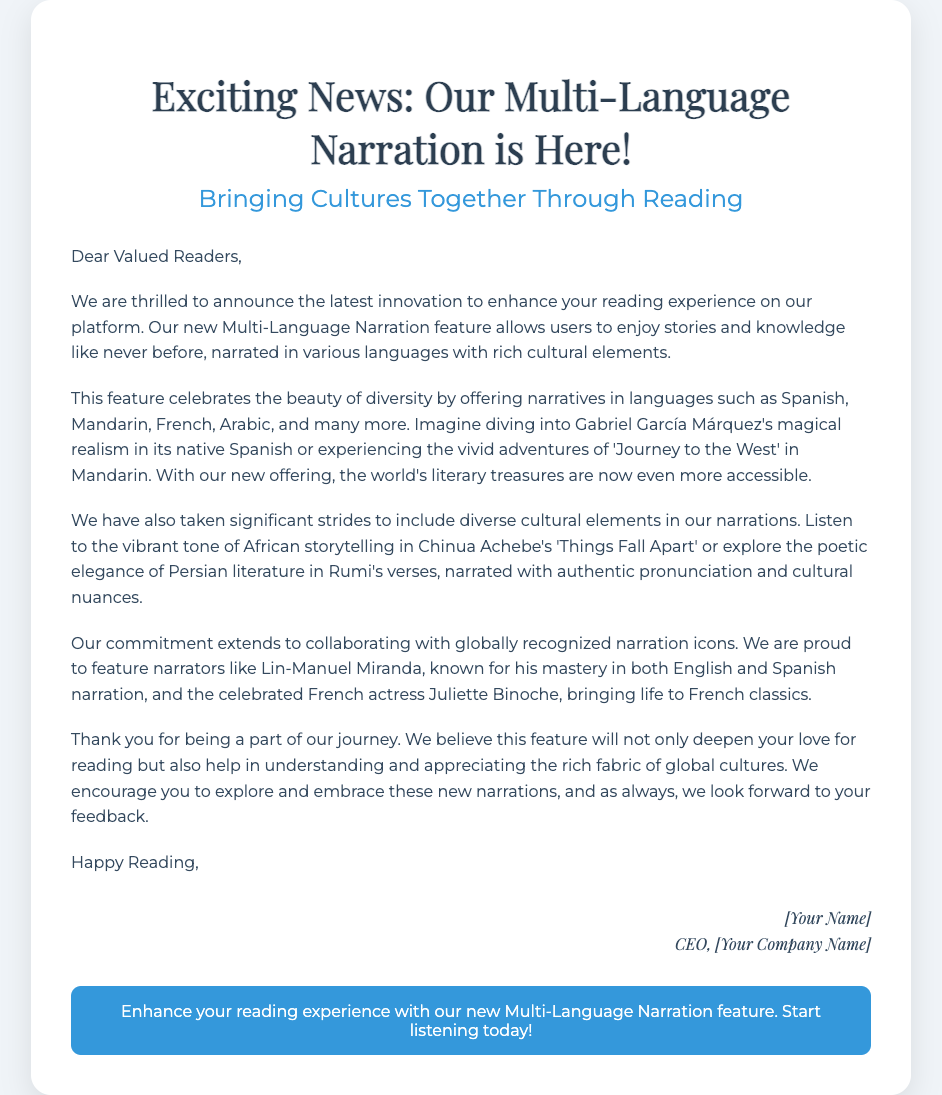What is the title of the announcement? The title of the announcement is prominently stated at the top of the document, which is "Exciting News: Our Multi-Language Narration is Here!"
Answer: Exciting News: Our Multi-Language Narration is Here! What feature is being announced? The document highlights a new feature specifically aimed at enhancing the reading experience, which is the Multi-Language Narration.
Answer: Multi-Language Narration Which languages are included in the new feature? The document lists several languages that are part of the new feature, including Spanish, Mandarin, French, and Arabic.
Answer: Spanish, Mandarin, French, Arabic Who is one of the notable narrators mentioned? The document mentions specific narrators who are involved with the new feature, one of which is Lin-Manuel Miranda.
Answer: Lin-Manuel Miranda What cultural elements are included in the narrations? The document mentions that the narrations incorporate diverse cultural elements, enhancing the storytelling experience with authenticity.
Answer: Diverse cultural elements What is the purpose of this new feature? The document indicates the purpose of the new feature is to deepen love for reading and help understand and appreciate global cultures.
Answer: Deepen love for reading How does the document address the readers? The document begins with a warm greeting directly addressing the audience as "Dear Valued Readers," creating a personal connection.
Answer: Dear Valued Readers What does the footer encourage readers to do? At the bottom of the document, the footer provides a call to action, encouraging readers to enhance their reading experience with the new feature.
Answer: Start listening today! 